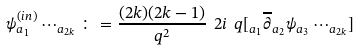<formula> <loc_0><loc_0><loc_500><loc_500>\psi ^ { ( i n ) } _ { a { _ { 1 } } } \cdots _ { a { _ { 2 k } } } \colon = \frac { ( 2 k ) ( 2 k - 1 ) } { q ^ { 2 } } \ 2 i \ q [ _ { a { _ { 1 } } } \overline { \partial } _ { a { _ { 2 } } } \psi _ { a { _ { 3 } } } \cdots _ { a { _ { 2 k } } } ]</formula> 